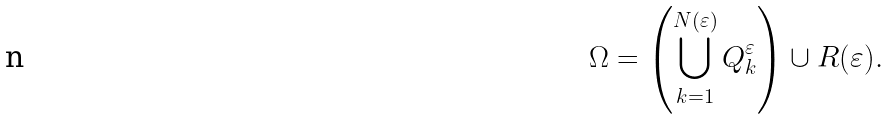<formula> <loc_0><loc_0><loc_500><loc_500>\Omega = \left ( \bigcup _ { k = 1 } ^ { N ( \varepsilon ) } Q ^ { \varepsilon } _ { k } \right ) \cup R ( \varepsilon ) .</formula> 